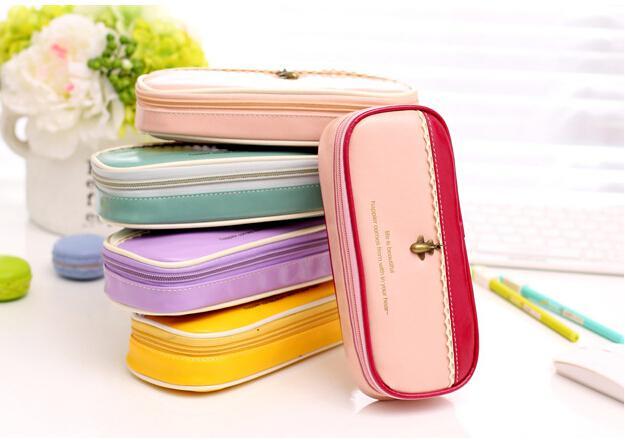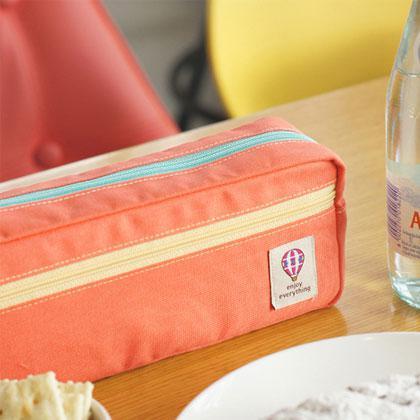The first image is the image on the left, the second image is the image on the right. For the images shown, is this caption "There's exactly four small bags in the left image." true? Answer yes or no. No. The first image is the image on the left, the second image is the image on the right. Examine the images to the left and right. Is the description "At least one image shows exactly four pencil cases of different solid colors." accurate? Answer yes or no. No. 